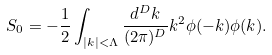<formula> <loc_0><loc_0><loc_500><loc_500>S _ { 0 } = - \frac { 1 } { 2 } \int _ { | k | < \Lambda } \frac { d ^ { D } k } { ( 2 \pi ) ^ { D } } k ^ { 2 } \phi ( - k ) \phi ( k ) .</formula> 